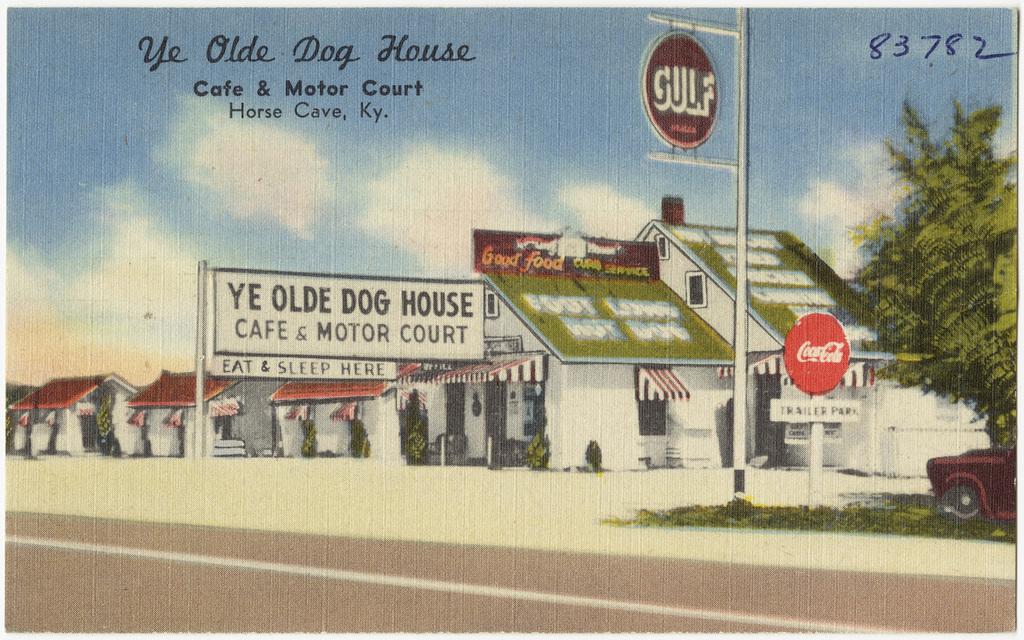What's the name of this cafe?
Your response must be concise. Ye olde dog house. What soda brand is seen on the sign for the cafe/motor?
Your answer should be very brief. Coca cola. 